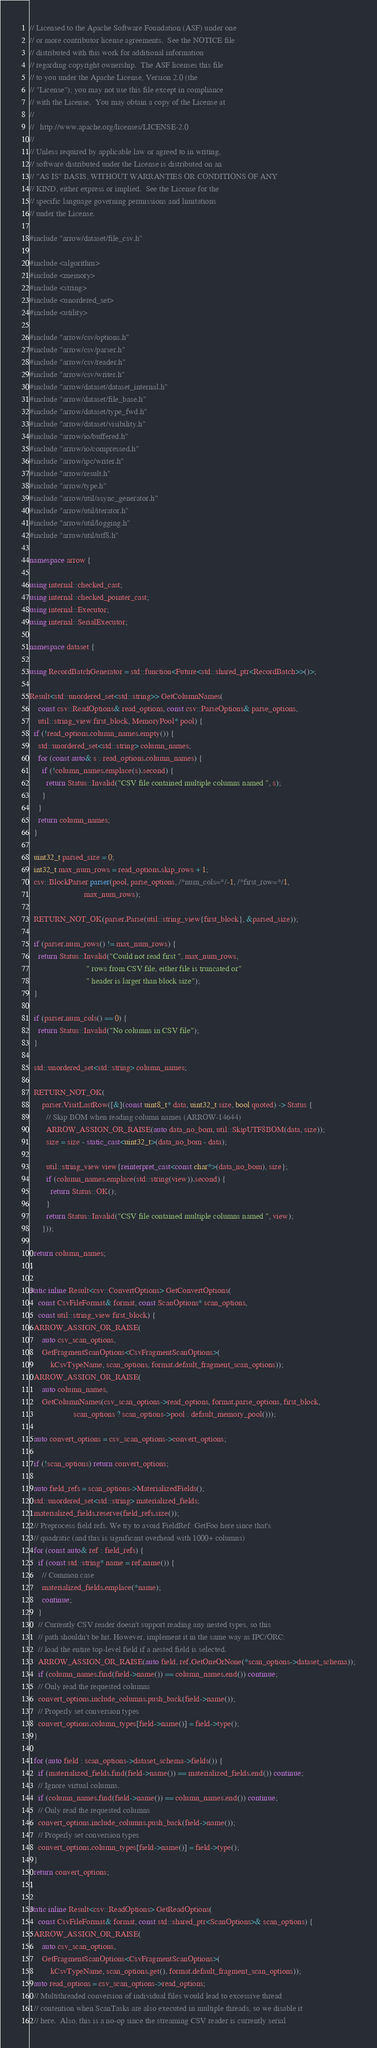Convert code to text. <code><loc_0><loc_0><loc_500><loc_500><_C++_>// Licensed to the Apache Software Foundation (ASF) under one
// or more contributor license agreements.  See the NOTICE file
// distributed with this work for additional information
// regarding copyright ownership.  The ASF licenses this file
// to you under the Apache License, Version 2.0 (the
// "License"); you may not use this file except in compliance
// with the License.  You may obtain a copy of the License at
//
//   http://www.apache.org/licenses/LICENSE-2.0
//
// Unless required by applicable law or agreed to in writing,
// software distributed under the License is distributed on an
// "AS IS" BASIS, WITHOUT WARRANTIES OR CONDITIONS OF ANY
// KIND, either express or implied.  See the License for the
// specific language governing permissions and limitations
// under the License.

#include "arrow/dataset/file_csv.h"

#include <algorithm>
#include <memory>
#include <string>
#include <unordered_set>
#include <utility>

#include "arrow/csv/options.h"
#include "arrow/csv/parser.h"
#include "arrow/csv/reader.h"
#include "arrow/csv/writer.h"
#include "arrow/dataset/dataset_internal.h"
#include "arrow/dataset/file_base.h"
#include "arrow/dataset/type_fwd.h"
#include "arrow/dataset/visibility.h"
#include "arrow/io/buffered.h"
#include "arrow/io/compressed.h"
#include "arrow/ipc/writer.h"
#include "arrow/result.h"
#include "arrow/type.h"
#include "arrow/util/async_generator.h"
#include "arrow/util/iterator.h"
#include "arrow/util/logging.h"
#include "arrow/util/utf8.h"

namespace arrow {

using internal::checked_cast;
using internal::checked_pointer_cast;
using internal::Executor;
using internal::SerialExecutor;

namespace dataset {

using RecordBatchGenerator = std::function<Future<std::shared_ptr<RecordBatch>>()>;

Result<std::unordered_set<std::string>> GetColumnNames(
    const csv::ReadOptions& read_options, const csv::ParseOptions& parse_options,
    util::string_view first_block, MemoryPool* pool) {
  if (!read_options.column_names.empty()) {
    std::unordered_set<std::string> column_names;
    for (const auto& s : read_options.column_names) {
      if (!column_names.emplace(s).second) {
        return Status::Invalid("CSV file contained multiple columns named ", s);
      }
    }
    return column_names;
  }

  uint32_t parsed_size = 0;
  int32_t max_num_rows = read_options.skip_rows + 1;
  csv::BlockParser parser(pool, parse_options, /*num_cols=*/-1, /*first_row=*/1,
                          max_num_rows);

  RETURN_NOT_OK(parser.Parse(util::string_view{first_block}, &parsed_size));

  if (parser.num_rows() != max_num_rows) {
    return Status::Invalid("Could not read first ", max_num_rows,
                           " rows from CSV file, either file is truncated or"
                           " header is larger than block size");
  }

  if (parser.num_cols() == 0) {
    return Status::Invalid("No columns in CSV file");
  }

  std::unordered_set<std::string> column_names;

  RETURN_NOT_OK(
      parser.VisitLastRow([&](const uint8_t* data, uint32_t size, bool quoted) -> Status {
        // Skip BOM when reading column names (ARROW-14644)
        ARROW_ASSIGN_OR_RAISE(auto data_no_bom, util::SkipUTF8BOM(data, size));
        size = size - static_cast<uint32_t>(data_no_bom - data);

        util::string_view view{reinterpret_cast<const char*>(data_no_bom), size};
        if (column_names.emplace(std::string(view)).second) {
          return Status::OK();
        }
        return Status::Invalid("CSV file contained multiple columns named ", view);
      }));

  return column_names;
}

static inline Result<csv::ConvertOptions> GetConvertOptions(
    const CsvFileFormat& format, const ScanOptions* scan_options,
    const util::string_view first_block) {
  ARROW_ASSIGN_OR_RAISE(
      auto csv_scan_options,
      GetFragmentScanOptions<CsvFragmentScanOptions>(
          kCsvTypeName, scan_options, format.default_fragment_scan_options));
  ARROW_ASSIGN_OR_RAISE(
      auto column_names,
      GetColumnNames(csv_scan_options->read_options, format.parse_options, first_block,
                     scan_options ? scan_options->pool : default_memory_pool()));

  auto convert_options = csv_scan_options->convert_options;

  if (!scan_options) return convert_options;

  auto field_refs = scan_options->MaterializedFields();
  std::unordered_set<std::string> materialized_fields;
  materialized_fields.reserve(field_refs.size());
  // Preprocess field refs. We try to avoid FieldRef::GetFoo here since that's
  // quadratic (and this is significant overhead with 1000+ columns)
  for (const auto& ref : field_refs) {
    if (const std::string* name = ref.name()) {
      // Common case
      materialized_fields.emplace(*name);
      continue;
    }
    // Currently CSV reader doesn't support reading any nested types, so this
    // path shouldn't be hit. However, implement it in the same way as IPC/ORC:
    // load the entire top-level field if a nested field is selected.
    ARROW_ASSIGN_OR_RAISE(auto field, ref.GetOneOrNone(*scan_options->dataset_schema));
    if (column_names.find(field->name()) == column_names.end()) continue;
    // Only read the requested columns
    convert_options.include_columns.push_back(field->name());
    // Properly set conversion types
    convert_options.column_types[field->name()] = field->type();
  }

  for (auto field : scan_options->dataset_schema->fields()) {
    if (materialized_fields.find(field->name()) == materialized_fields.end()) continue;
    // Ignore virtual columns.
    if (column_names.find(field->name()) == column_names.end()) continue;
    // Only read the requested columns
    convert_options.include_columns.push_back(field->name());
    // Properly set conversion types
    convert_options.column_types[field->name()] = field->type();
  }
  return convert_options;
}

static inline Result<csv::ReadOptions> GetReadOptions(
    const CsvFileFormat& format, const std::shared_ptr<ScanOptions>& scan_options) {
  ARROW_ASSIGN_OR_RAISE(
      auto csv_scan_options,
      GetFragmentScanOptions<CsvFragmentScanOptions>(
          kCsvTypeName, scan_options.get(), format.default_fragment_scan_options));
  auto read_options = csv_scan_options->read_options;
  // Multithreaded conversion of individual files would lead to excessive thread
  // contention when ScanTasks are also executed in multiple threads, so we disable it
  // here.  Also, this is a no-op since the streaming CSV reader is currently serial</code> 